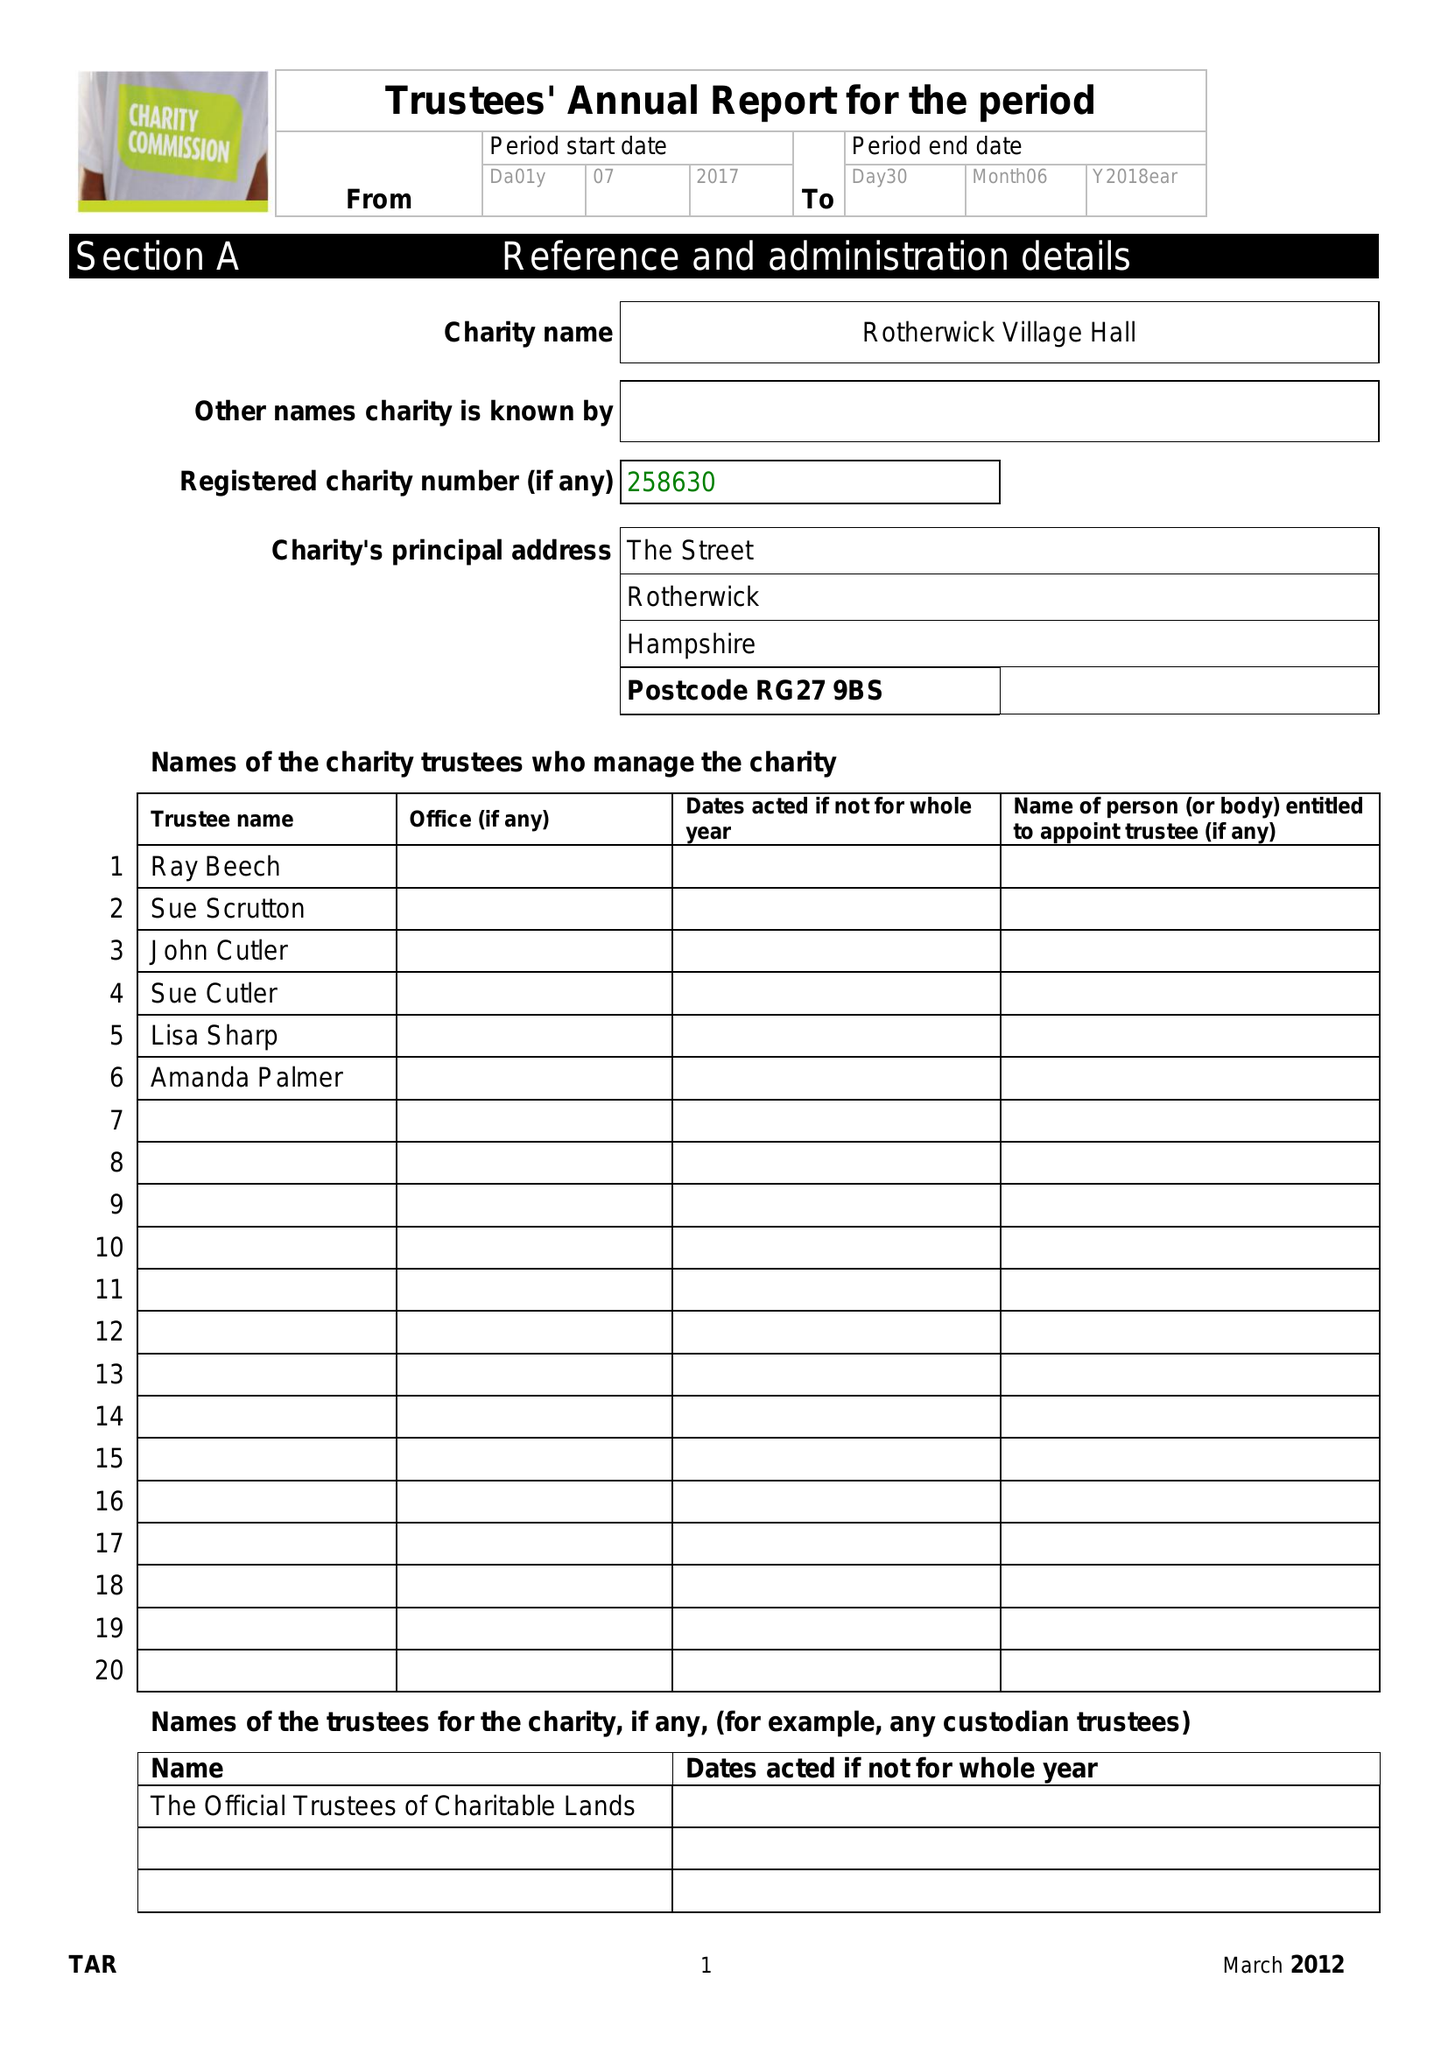What is the value for the charity_name?
Answer the question using a single word or phrase. Rotherwick Village Hall Charity 